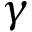Convert formula to latex. <formula><loc_0><loc_0><loc_500><loc_500>\gamma</formula> 